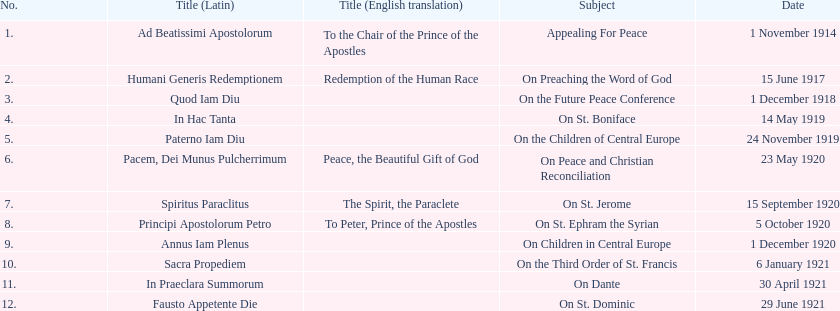In the table, how many titles can be counted? 12. 